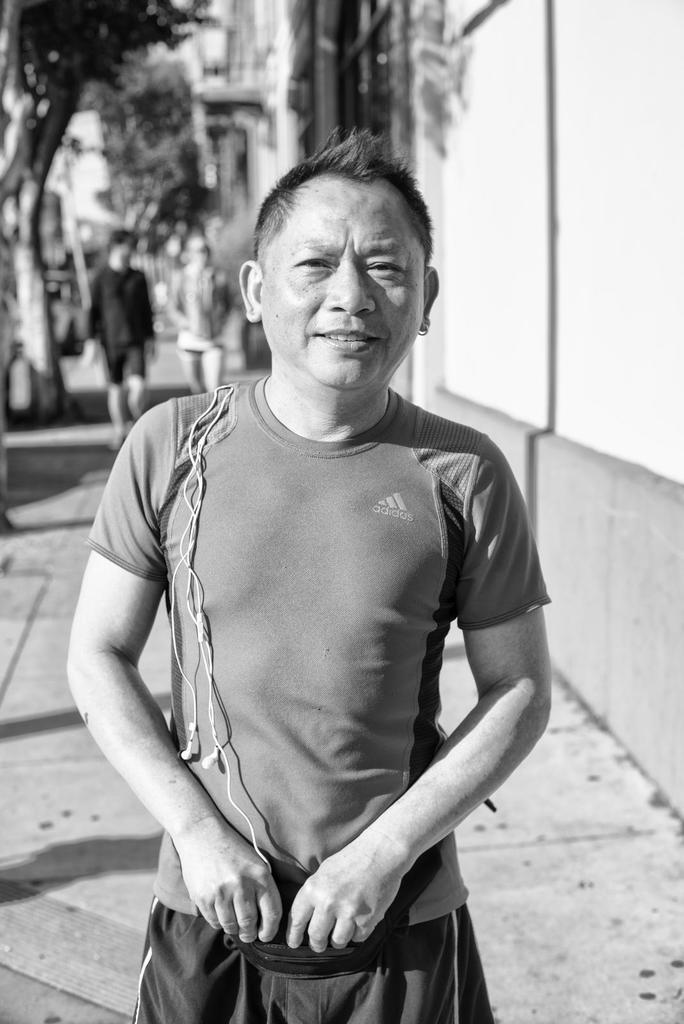What is the color scheme of the image? The image is black and white. Who is present in the image? There is a man in the image. What is the man's expression? The man is smiling. What can be seen in the background of the image? There is a wall and trees in the background of the image. What activity is happening in the background of the image? Two persons are walking on a footpath in the background of the image. What type of sand can be seen on the beach in the image? There is no beach or sand present in the image. How many pigs are visible in the image? There are no pigs present in the image. 